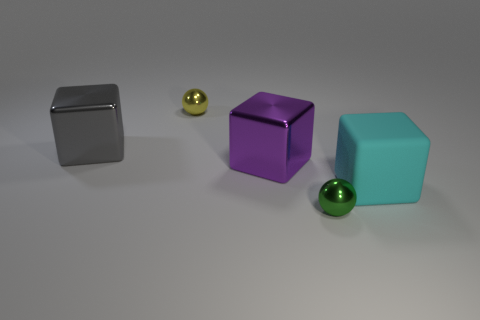Subtract all cyan cubes. Subtract all yellow balls. How many cubes are left? 2 Add 4 big purple metal blocks. How many objects exist? 9 Subtract all balls. How many objects are left? 3 Add 3 big purple metal things. How many big purple metal things exist? 4 Subtract 0 brown cylinders. How many objects are left? 5 Subtract all yellow objects. Subtract all cyan things. How many objects are left? 3 Add 1 green shiny spheres. How many green shiny spheres are left? 2 